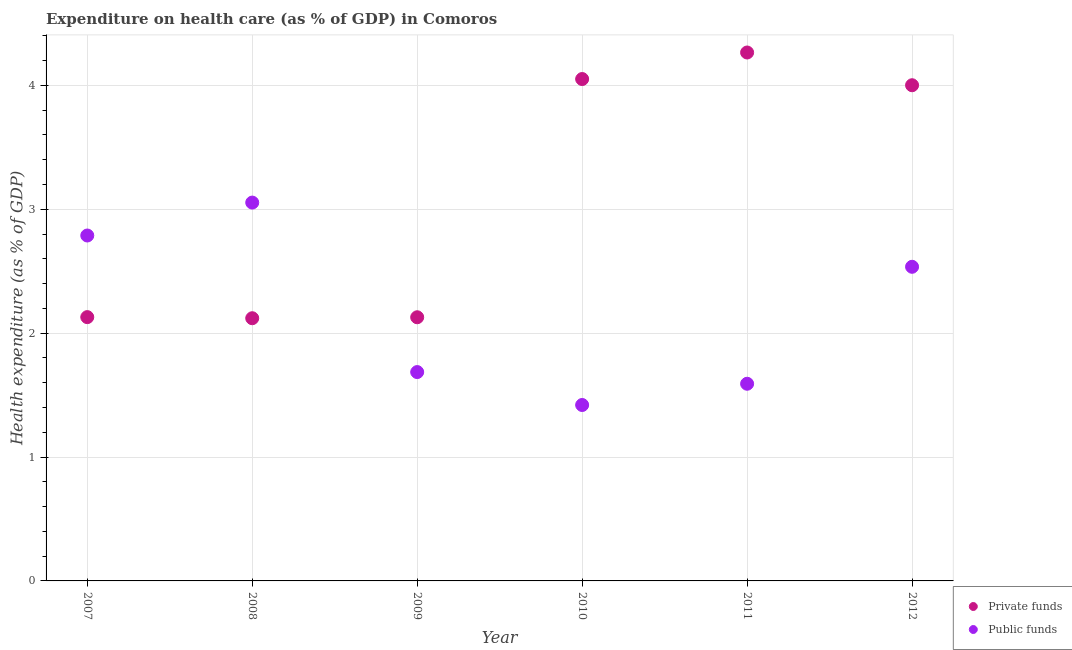Is the number of dotlines equal to the number of legend labels?
Your answer should be very brief. Yes. What is the amount of public funds spent in healthcare in 2008?
Make the answer very short. 3.05. Across all years, what is the maximum amount of private funds spent in healthcare?
Offer a very short reply. 4.27. Across all years, what is the minimum amount of public funds spent in healthcare?
Your answer should be very brief. 1.42. In which year was the amount of private funds spent in healthcare minimum?
Your answer should be very brief. 2008. What is the total amount of private funds spent in healthcare in the graph?
Your response must be concise. 18.69. What is the difference between the amount of private funds spent in healthcare in 2008 and that in 2009?
Give a very brief answer. -0.01. What is the difference between the amount of private funds spent in healthcare in 2012 and the amount of public funds spent in healthcare in 2008?
Give a very brief answer. 0.95. What is the average amount of private funds spent in healthcare per year?
Provide a short and direct response. 3.12. In the year 2010, what is the difference between the amount of public funds spent in healthcare and amount of private funds spent in healthcare?
Your response must be concise. -2.63. What is the ratio of the amount of private funds spent in healthcare in 2008 to that in 2011?
Provide a succinct answer. 0.5. What is the difference between the highest and the second highest amount of public funds spent in healthcare?
Your answer should be compact. 0.27. What is the difference between the highest and the lowest amount of private funds spent in healthcare?
Your response must be concise. 2.14. In how many years, is the amount of public funds spent in healthcare greater than the average amount of public funds spent in healthcare taken over all years?
Provide a short and direct response. 3. Is the sum of the amount of private funds spent in healthcare in 2008 and 2010 greater than the maximum amount of public funds spent in healthcare across all years?
Provide a short and direct response. Yes. Is the amount of public funds spent in healthcare strictly less than the amount of private funds spent in healthcare over the years?
Offer a terse response. No. How many dotlines are there?
Provide a succinct answer. 2. Are the values on the major ticks of Y-axis written in scientific E-notation?
Your answer should be compact. No. Where does the legend appear in the graph?
Give a very brief answer. Bottom right. How many legend labels are there?
Provide a short and direct response. 2. How are the legend labels stacked?
Provide a succinct answer. Vertical. What is the title of the graph?
Your answer should be compact. Expenditure on health care (as % of GDP) in Comoros. What is the label or title of the Y-axis?
Keep it short and to the point. Health expenditure (as % of GDP). What is the Health expenditure (as % of GDP) of Private funds in 2007?
Your response must be concise. 2.13. What is the Health expenditure (as % of GDP) of Public funds in 2007?
Make the answer very short. 2.79. What is the Health expenditure (as % of GDP) of Private funds in 2008?
Your response must be concise. 2.12. What is the Health expenditure (as % of GDP) of Public funds in 2008?
Ensure brevity in your answer.  3.05. What is the Health expenditure (as % of GDP) of Private funds in 2009?
Offer a very short reply. 2.13. What is the Health expenditure (as % of GDP) of Public funds in 2009?
Offer a very short reply. 1.69. What is the Health expenditure (as % of GDP) in Private funds in 2010?
Your answer should be compact. 4.05. What is the Health expenditure (as % of GDP) of Public funds in 2010?
Give a very brief answer. 1.42. What is the Health expenditure (as % of GDP) of Private funds in 2011?
Give a very brief answer. 4.27. What is the Health expenditure (as % of GDP) of Public funds in 2011?
Your answer should be very brief. 1.59. What is the Health expenditure (as % of GDP) in Private funds in 2012?
Provide a succinct answer. 4. What is the Health expenditure (as % of GDP) in Public funds in 2012?
Your response must be concise. 2.54. Across all years, what is the maximum Health expenditure (as % of GDP) of Private funds?
Ensure brevity in your answer.  4.27. Across all years, what is the maximum Health expenditure (as % of GDP) of Public funds?
Your response must be concise. 3.05. Across all years, what is the minimum Health expenditure (as % of GDP) of Private funds?
Your response must be concise. 2.12. Across all years, what is the minimum Health expenditure (as % of GDP) of Public funds?
Make the answer very short. 1.42. What is the total Health expenditure (as % of GDP) of Private funds in the graph?
Make the answer very short. 18.69. What is the total Health expenditure (as % of GDP) in Public funds in the graph?
Keep it short and to the point. 13.07. What is the difference between the Health expenditure (as % of GDP) of Private funds in 2007 and that in 2008?
Ensure brevity in your answer.  0.01. What is the difference between the Health expenditure (as % of GDP) in Public funds in 2007 and that in 2008?
Keep it short and to the point. -0.27. What is the difference between the Health expenditure (as % of GDP) in Private funds in 2007 and that in 2009?
Your response must be concise. 0. What is the difference between the Health expenditure (as % of GDP) of Public funds in 2007 and that in 2009?
Make the answer very short. 1.1. What is the difference between the Health expenditure (as % of GDP) in Private funds in 2007 and that in 2010?
Your response must be concise. -1.92. What is the difference between the Health expenditure (as % of GDP) in Public funds in 2007 and that in 2010?
Provide a short and direct response. 1.37. What is the difference between the Health expenditure (as % of GDP) of Private funds in 2007 and that in 2011?
Provide a succinct answer. -2.14. What is the difference between the Health expenditure (as % of GDP) in Public funds in 2007 and that in 2011?
Provide a short and direct response. 1.2. What is the difference between the Health expenditure (as % of GDP) of Private funds in 2007 and that in 2012?
Offer a very short reply. -1.87. What is the difference between the Health expenditure (as % of GDP) of Public funds in 2007 and that in 2012?
Your answer should be compact. 0.25. What is the difference between the Health expenditure (as % of GDP) in Private funds in 2008 and that in 2009?
Give a very brief answer. -0.01. What is the difference between the Health expenditure (as % of GDP) of Public funds in 2008 and that in 2009?
Your response must be concise. 1.37. What is the difference between the Health expenditure (as % of GDP) in Private funds in 2008 and that in 2010?
Keep it short and to the point. -1.93. What is the difference between the Health expenditure (as % of GDP) in Public funds in 2008 and that in 2010?
Your response must be concise. 1.63. What is the difference between the Health expenditure (as % of GDP) in Private funds in 2008 and that in 2011?
Keep it short and to the point. -2.14. What is the difference between the Health expenditure (as % of GDP) of Public funds in 2008 and that in 2011?
Your response must be concise. 1.46. What is the difference between the Health expenditure (as % of GDP) of Private funds in 2008 and that in 2012?
Keep it short and to the point. -1.88. What is the difference between the Health expenditure (as % of GDP) in Public funds in 2008 and that in 2012?
Your answer should be compact. 0.52. What is the difference between the Health expenditure (as % of GDP) in Private funds in 2009 and that in 2010?
Your answer should be very brief. -1.92. What is the difference between the Health expenditure (as % of GDP) in Public funds in 2009 and that in 2010?
Give a very brief answer. 0.27. What is the difference between the Health expenditure (as % of GDP) in Private funds in 2009 and that in 2011?
Your answer should be compact. -2.14. What is the difference between the Health expenditure (as % of GDP) in Public funds in 2009 and that in 2011?
Ensure brevity in your answer.  0.09. What is the difference between the Health expenditure (as % of GDP) of Private funds in 2009 and that in 2012?
Ensure brevity in your answer.  -1.87. What is the difference between the Health expenditure (as % of GDP) of Public funds in 2009 and that in 2012?
Your response must be concise. -0.85. What is the difference between the Health expenditure (as % of GDP) in Private funds in 2010 and that in 2011?
Provide a short and direct response. -0.21. What is the difference between the Health expenditure (as % of GDP) of Public funds in 2010 and that in 2011?
Provide a succinct answer. -0.17. What is the difference between the Health expenditure (as % of GDP) in Public funds in 2010 and that in 2012?
Provide a succinct answer. -1.12. What is the difference between the Health expenditure (as % of GDP) in Private funds in 2011 and that in 2012?
Keep it short and to the point. 0.26. What is the difference between the Health expenditure (as % of GDP) of Public funds in 2011 and that in 2012?
Provide a short and direct response. -0.94. What is the difference between the Health expenditure (as % of GDP) of Private funds in 2007 and the Health expenditure (as % of GDP) of Public funds in 2008?
Give a very brief answer. -0.92. What is the difference between the Health expenditure (as % of GDP) of Private funds in 2007 and the Health expenditure (as % of GDP) of Public funds in 2009?
Your response must be concise. 0.44. What is the difference between the Health expenditure (as % of GDP) in Private funds in 2007 and the Health expenditure (as % of GDP) in Public funds in 2010?
Make the answer very short. 0.71. What is the difference between the Health expenditure (as % of GDP) in Private funds in 2007 and the Health expenditure (as % of GDP) in Public funds in 2011?
Offer a very short reply. 0.54. What is the difference between the Health expenditure (as % of GDP) of Private funds in 2007 and the Health expenditure (as % of GDP) of Public funds in 2012?
Give a very brief answer. -0.41. What is the difference between the Health expenditure (as % of GDP) of Private funds in 2008 and the Health expenditure (as % of GDP) of Public funds in 2009?
Offer a very short reply. 0.43. What is the difference between the Health expenditure (as % of GDP) of Private funds in 2008 and the Health expenditure (as % of GDP) of Public funds in 2010?
Keep it short and to the point. 0.7. What is the difference between the Health expenditure (as % of GDP) of Private funds in 2008 and the Health expenditure (as % of GDP) of Public funds in 2011?
Offer a very short reply. 0.53. What is the difference between the Health expenditure (as % of GDP) of Private funds in 2008 and the Health expenditure (as % of GDP) of Public funds in 2012?
Keep it short and to the point. -0.42. What is the difference between the Health expenditure (as % of GDP) in Private funds in 2009 and the Health expenditure (as % of GDP) in Public funds in 2010?
Provide a short and direct response. 0.71. What is the difference between the Health expenditure (as % of GDP) in Private funds in 2009 and the Health expenditure (as % of GDP) in Public funds in 2011?
Provide a short and direct response. 0.54. What is the difference between the Health expenditure (as % of GDP) of Private funds in 2009 and the Health expenditure (as % of GDP) of Public funds in 2012?
Offer a very short reply. -0.41. What is the difference between the Health expenditure (as % of GDP) in Private funds in 2010 and the Health expenditure (as % of GDP) in Public funds in 2011?
Offer a terse response. 2.46. What is the difference between the Health expenditure (as % of GDP) in Private funds in 2010 and the Health expenditure (as % of GDP) in Public funds in 2012?
Ensure brevity in your answer.  1.52. What is the difference between the Health expenditure (as % of GDP) of Private funds in 2011 and the Health expenditure (as % of GDP) of Public funds in 2012?
Provide a short and direct response. 1.73. What is the average Health expenditure (as % of GDP) in Private funds per year?
Provide a short and direct response. 3.12. What is the average Health expenditure (as % of GDP) of Public funds per year?
Offer a terse response. 2.18. In the year 2007, what is the difference between the Health expenditure (as % of GDP) of Private funds and Health expenditure (as % of GDP) of Public funds?
Your answer should be very brief. -0.66. In the year 2008, what is the difference between the Health expenditure (as % of GDP) in Private funds and Health expenditure (as % of GDP) in Public funds?
Offer a very short reply. -0.93. In the year 2009, what is the difference between the Health expenditure (as % of GDP) in Private funds and Health expenditure (as % of GDP) in Public funds?
Your answer should be compact. 0.44. In the year 2010, what is the difference between the Health expenditure (as % of GDP) in Private funds and Health expenditure (as % of GDP) in Public funds?
Your response must be concise. 2.63. In the year 2011, what is the difference between the Health expenditure (as % of GDP) of Private funds and Health expenditure (as % of GDP) of Public funds?
Your response must be concise. 2.67. In the year 2012, what is the difference between the Health expenditure (as % of GDP) of Private funds and Health expenditure (as % of GDP) of Public funds?
Make the answer very short. 1.47. What is the ratio of the Health expenditure (as % of GDP) of Private funds in 2007 to that in 2008?
Provide a succinct answer. 1. What is the ratio of the Health expenditure (as % of GDP) in Private funds in 2007 to that in 2009?
Your answer should be compact. 1. What is the ratio of the Health expenditure (as % of GDP) in Public funds in 2007 to that in 2009?
Your answer should be compact. 1.65. What is the ratio of the Health expenditure (as % of GDP) in Private funds in 2007 to that in 2010?
Provide a succinct answer. 0.53. What is the ratio of the Health expenditure (as % of GDP) in Public funds in 2007 to that in 2010?
Ensure brevity in your answer.  1.96. What is the ratio of the Health expenditure (as % of GDP) in Private funds in 2007 to that in 2011?
Your answer should be compact. 0.5. What is the ratio of the Health expenditure (as % of GDP) in Public funds in 2007 to that in 2011?
Keep it short and to the point. 1.75. What is the ratio of the Health expenditure (as % of GDP) of Private funds in 2007 to that in 2012?
Your answer should be very brief. 0.53. What is the ratio of the Health expenditure (as % of GDP) of Public funds in 2007 to that in 2012?
Offer a terse response. 1.1. What is the ratio of the Health expenditure (as % of GDP) of Private funds in 2008 to that in 2009?
Ensure brevity in your answer.  1. What is the ratio of the Health expenditure (as % of GDP) in Public funds in 2008 to that in 2009?
Your response must be concise. 1.81. What is the ratio of the Health expenditure (as % of GDP) in Private funds in 2008 to that in 2010?
Provide a short and direct response. 0.52. What is the ratio of the Health expenditure (as % of GDP) in Public funds in 2008 to that in 2010?
Offer a very short reply. 2.15. What is the ratio of the Health expenditure (as % of GDP) of Private funds in 2008 to that in 2011?
Ensure brevity in your answer.  0.5. What is the ratio of the Health expenditure (as % of GDP) of Public funds in 2008 to that in 2011?
Give a very brief answer. 1.92. What is the ratio of the Health expenditure (as % of GDP) in Private funds in 2008 to that in 2012?
Make the answer very short. 0.53. What is the ratio of the Health expenditure (as % of GDP) in Public funds in 2008 to that in 2012?
Make the answer very short. 1.2. What is the ratio of the Health expenditure (as % of GDP) in Private funds in 2009 to that in 2010?
Your answer should be compact. 0.53. What is the ratio of the Health expenditure (as % of GDP) in Public funds in 2009 to that in 2010?
Ensure brevity in your answer.  1.19. What is the ratio of the Health expenditure (as % of GDP) in Private funds in 2009 to that in 2011?
Offer a very short reply. 0.5. What is the ratio of the Health expenditure (as % of GDP) in Public funds in 2009 to that in 2011?
Offer a very short reply. 1.06. What is the ratio of the Health expenditure (as % of GDP) of Private funds in 2009 to that in 2012?
Offer a very short reply. 0.53. What is the ratio of the Health expenditure (as % of GDP) in Public funds in 2009 to that in 2012?
Offer a very short reply. 0.66. What is the ratio of the Health expenditure (as % of GDP) in Private funds in 2010 to that in 2011?
Offer a very short reply. 0.95. What is the ratio of the Health expenditure (as % of GDP) in Public funds in 2010 to that in 2011?
Offer a very short reply. 0.89. What is the ratio of the Health expenditure (as % of GDP) in Private funds in 2010 to that in 2012?
Your response must be concise. 1.01. What is the ratio of the Health expenditure (as % of GDP) of Public funds in 2010 to that in 2012?
Your answer should be very brief. 0.56. What is the ratio of the Health expenditure (as % of GDP) of Private funds in 2011 to that in 2012?
Your response must be concise. 1.07. What is the ratio of the Health expenditure (as % of GDP) in Public funds in 2011 to that in 2012?
Ensure brevity in your answer.  0.63. What is the difference between the highest and the second highest Health expenditure (as % of GDP) of Private funds?
Offer a terse response. 0.21. What is the difference between the highest and the second highest Health expenditure (as % of GDP) of Public funds?
Offer a very short reply. 0.27. What is the difference between the highest and the lowest Health expenditure (as % of GDP) in Private funds?
Offer a terse response. 2.14. What is the difference between the highest and the lowest Health expenditure (as % of GDP) in Public funds?
Your response must be concise. 1.63. 